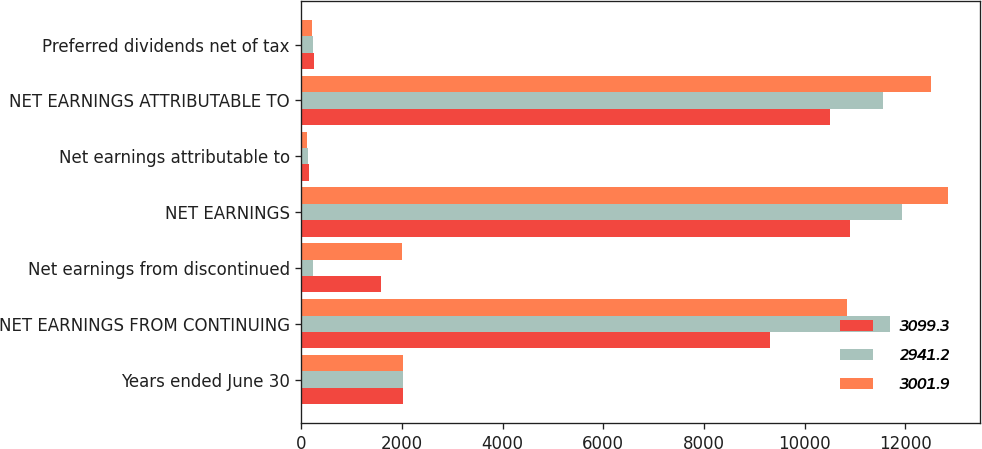<chart> <loc_0><loc_0><loc_500><loc_500><stacked_bar_chart><ecel><fcel>Years ended June 30<fcel>NET EARNINGS FROM CONTINUING<fcel>Net earnings from discontinued<fcel>NET EARNINGS<fcel>Net earnings attributable to<fcel>NET EARNINGS ATTRIBUTABLE TO<fcel>Preferred dividends net of tax<nl><fcel>3099.3<fcel>2012<fcel>9317<fcel>1587<fcel>10904<fcel>148<fcel>10500<fcel>256<nl><fcel>2941.2<fcel>2011<fcel>11698<fcel>229<fcel>11927<fcel>130<fcel>11564<fcel>233<nl><fcel>3001.9<fcel>2010<fcel>10851<fcel>1995<fcel>12846<fcel>110<fcel>12517<fcel>219<nl></chart> 